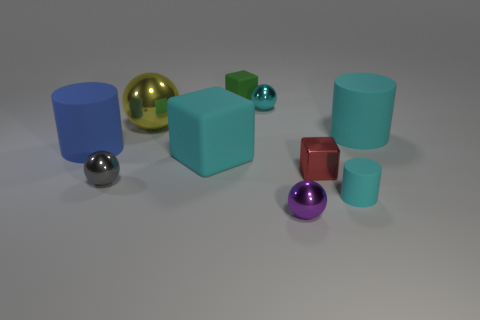The cylinder that is left of the tiny red thing is what color?
Offer a terse response. Blue. How many large cylinders are the same color as the small rubber cube?
Make the answer very short. 0. Is the number of small cyan spheres left of the tiny gray metal ball less than the number of small purple balls that are in front of the purple thing?
Ensure brevity in your answer.  No. There is a purple shiny thing; what number of things are in front of it?
Your answer should be compact. 0. Are there any blue cylinders made of the same material as the cyan ball?
Give a very brief answer. No. Are there more cyan matte cubes right of the large cyan cylinder than large cylinders that are to the right of the metallic block?
Offer a very short reply. No. What is the size of the yellow shiny ball?
Keep it short and to the point. Large. What shape is the large cyan object that is right of the green cube?
Your answer should be very brief. Cylinder. Does the yellow thing have the same shape as the small purple object?
Your answer should be very brief. Yes. Are there the same number of red metallic cubes behind the red object and small matte cylinders?
Your answer should be very brief. No. 